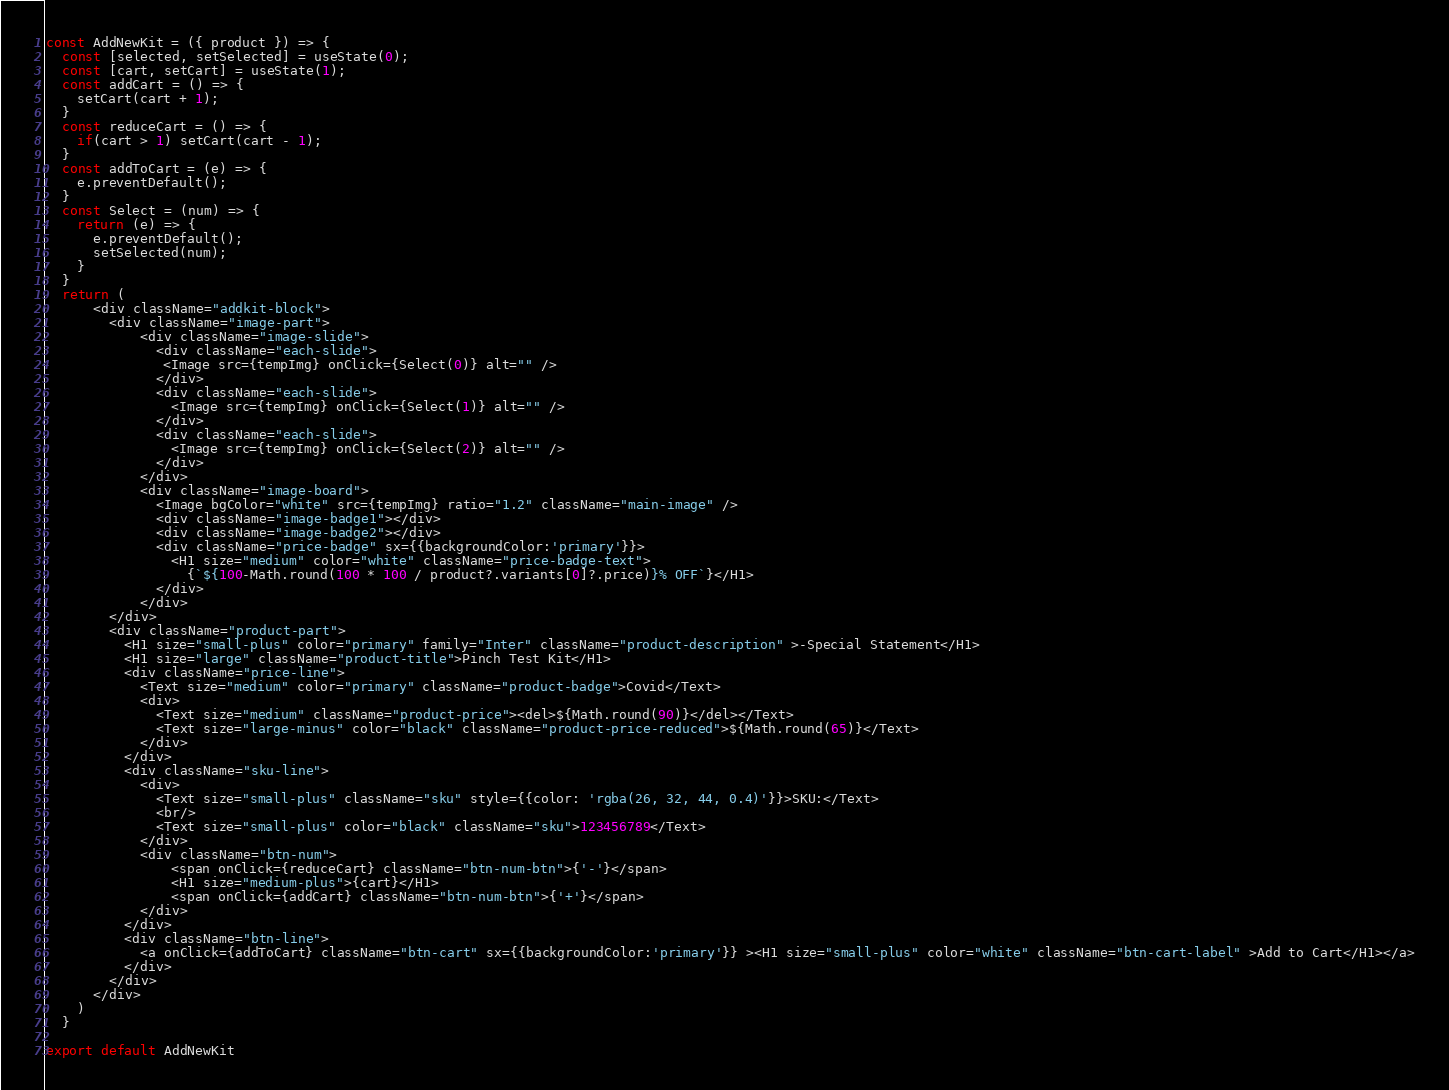Convert code to text. <code><loc_0><loc_0><loc_500><loc_500><_JavaScript_>
const AddNewKit = ({ product }) => {
  const [selected, setSelected] = useState(0);
  const [cart, setCart] = useState(1);
  const addCart = () => {
    setCart(cart + 1);
  }
  const reduceCart = () => {
    if(cart > 1) setCart(cart - 1);
  }
  const addToCart = (e) => {
    e.preventDefault();
  }
  const Select = (num) => {
    return (e) => {
      e.preventDefault();
      setSelected(num);
    }
  }
  return (
      <div className="addkit-block">
        <div className="image-part">
            <div className="image-slide">
              <div className="each-slide">
               <Image src={tempImg} onClick={Select(0)} alt="" />
              </div>
              <div className="each-slide">
                <Image src={tempImg} onClick={Select(1)} alt="" />
              </div>
              <div className="each-slide">
                <Image src={tempImg} onClick={Select(2)} alt="" />
              </div>
            </div>
            <div className="image-board">
              <Image bgColor="white" src={tempImg} ratio="1.2" className="main-image" />
              <div className="image-badge1"></div>
              <div className="image-badge2"></div>
              <div className="price-badge" sx={{backgroundColor:'primary'}}>
                <H1 size="medium" color="white" className="price-badge-text">
                  {`${100-Math.round(100 * 100 / product?.variants[0]?.price)}% OFF`}</H1>
              </div>
            </div>
        </div>
        <div className="product-part">
          <H1 size="small-plus" color="primary" family="Inter" className="product-description" >-Special Statement</H1>
          <H1 size="large" className="product-title">Pinch Test Kit</H1>
          <div className="price-line">
            <Text size="medium" color="primary" className="product-badge">Covid</Text>
            <div>
              <Text size="medium" className="product-price"><del>${Math.round(90)}</del></Text>
              <Text size="large-minus" color="black" className="product-price-reduced">${Math.round(65)}</Text>
            </div>
          </div>
          <div className="sku-line">
            <div>
              <Text size="small-plus" className="sku" style={{color: 'rgba(26, 32, 44, 0.4)'}}>SKU:</Text>
              <br/>
              <Text size="small-plus" color="black" className="sku">123456789</Text>
            </div>
            <div className="btn-num">
                <span onClick={reduceCart} className="btn-num-btn">{'-'}</span>
                <H1 size="medium-plus">{cart}</H1>
                <span onClick={addCart} className="btn-num-btn">{'+'}</span>
            </div>
          </div>
          <div className="btn-line">
            <a onClick={addToCart} className="btn-cart" sx={{backgroundColor:'primary'}} ><H1 size="small-plus" color="white" className="btn-cart-label" >Add to Cart</H1></a>
          </div>
        </div>
      </div>
    )
  }

export default AddNewKit</code> 